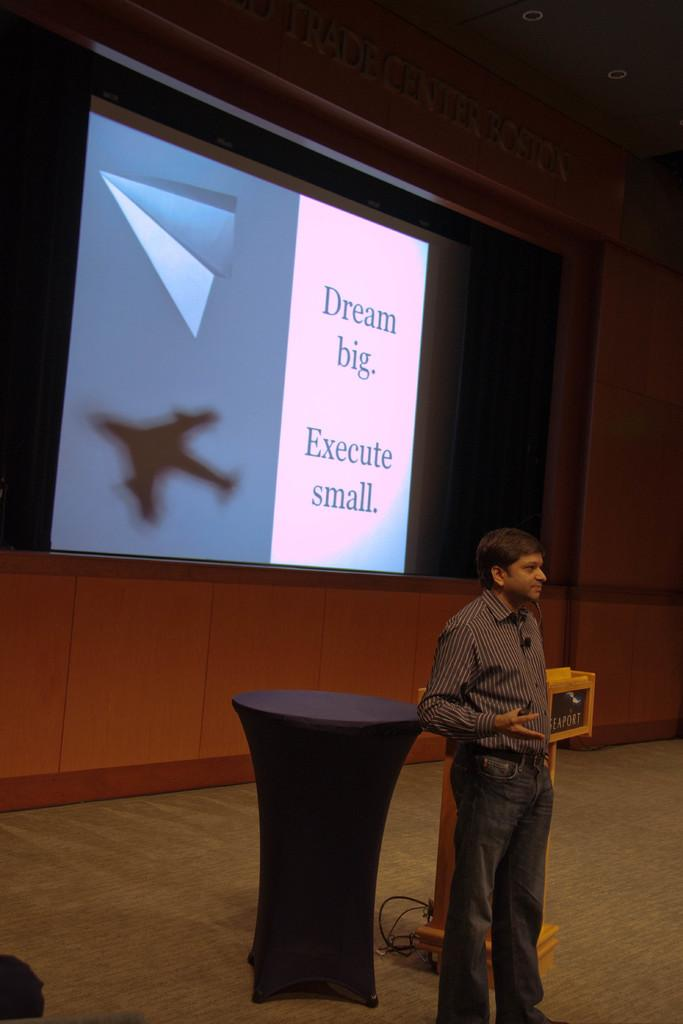What is the main subject in the image? There is a person standing in the image. What object is present near the person? There is a podium in the image. What other furniture is visible in the image? There is a table in the image. What can be seen in the background of the image? There is a screen and lights in the background of the image. How many legs does the donkey have in the image? There is no donkey present in the image, so it is not possible to determine the number of legs it might have. 